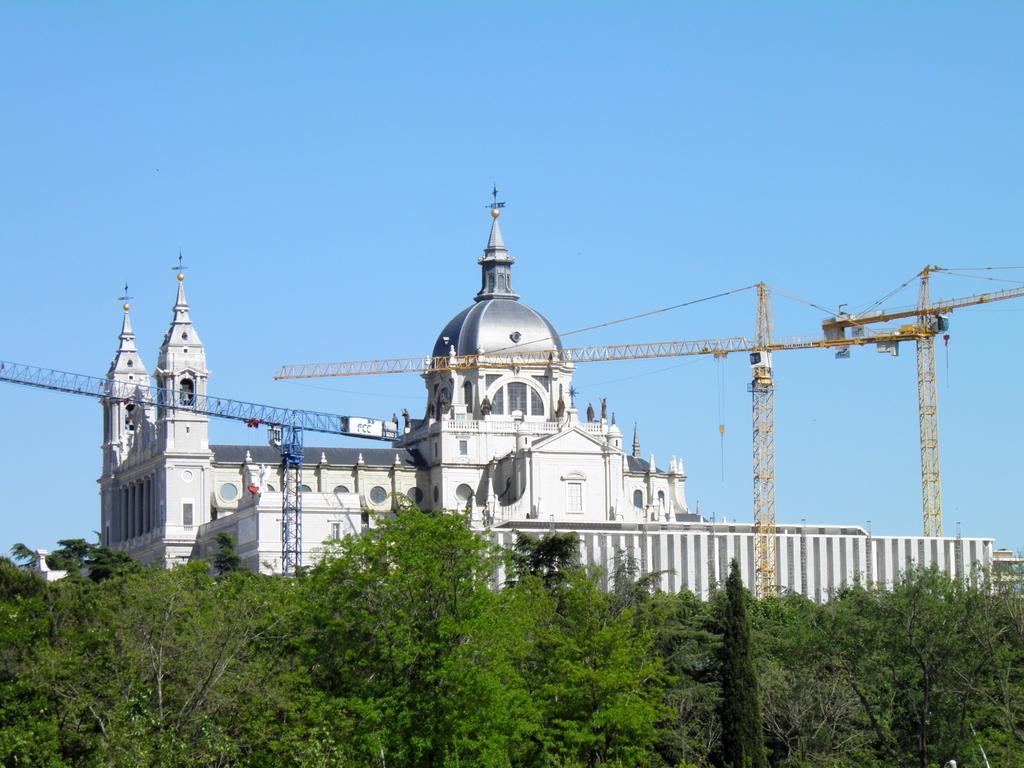Can you describe this image briefly? In this image we can see buildings, construction cranes, sky and trees. 